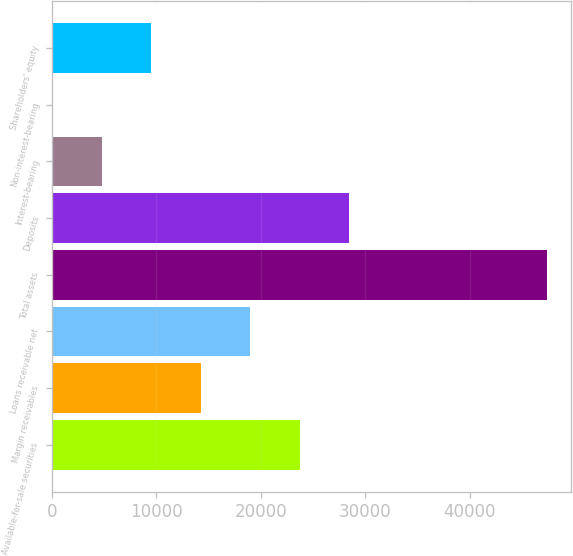Convert chart to OTSL. <chart><loc_0><loc_0><loc_500><loc_500><bar_chart><fcel>Available-for-sale securities<fcel>Margin receivables<fcel>Loans receivable net<fcel>Total assets<fcel>Deposits<fcel>Interest-bearing<fcel>Non-interest-bearing<fcel>Shareholders' equity<nl><fcel>23714.7<fcel>14245.9<fcel>18980.3<fcel>47386.7<fcel>28449.1<fcel>4777.1<fcel>42.7<fcel>9511.5<nl></chart> 